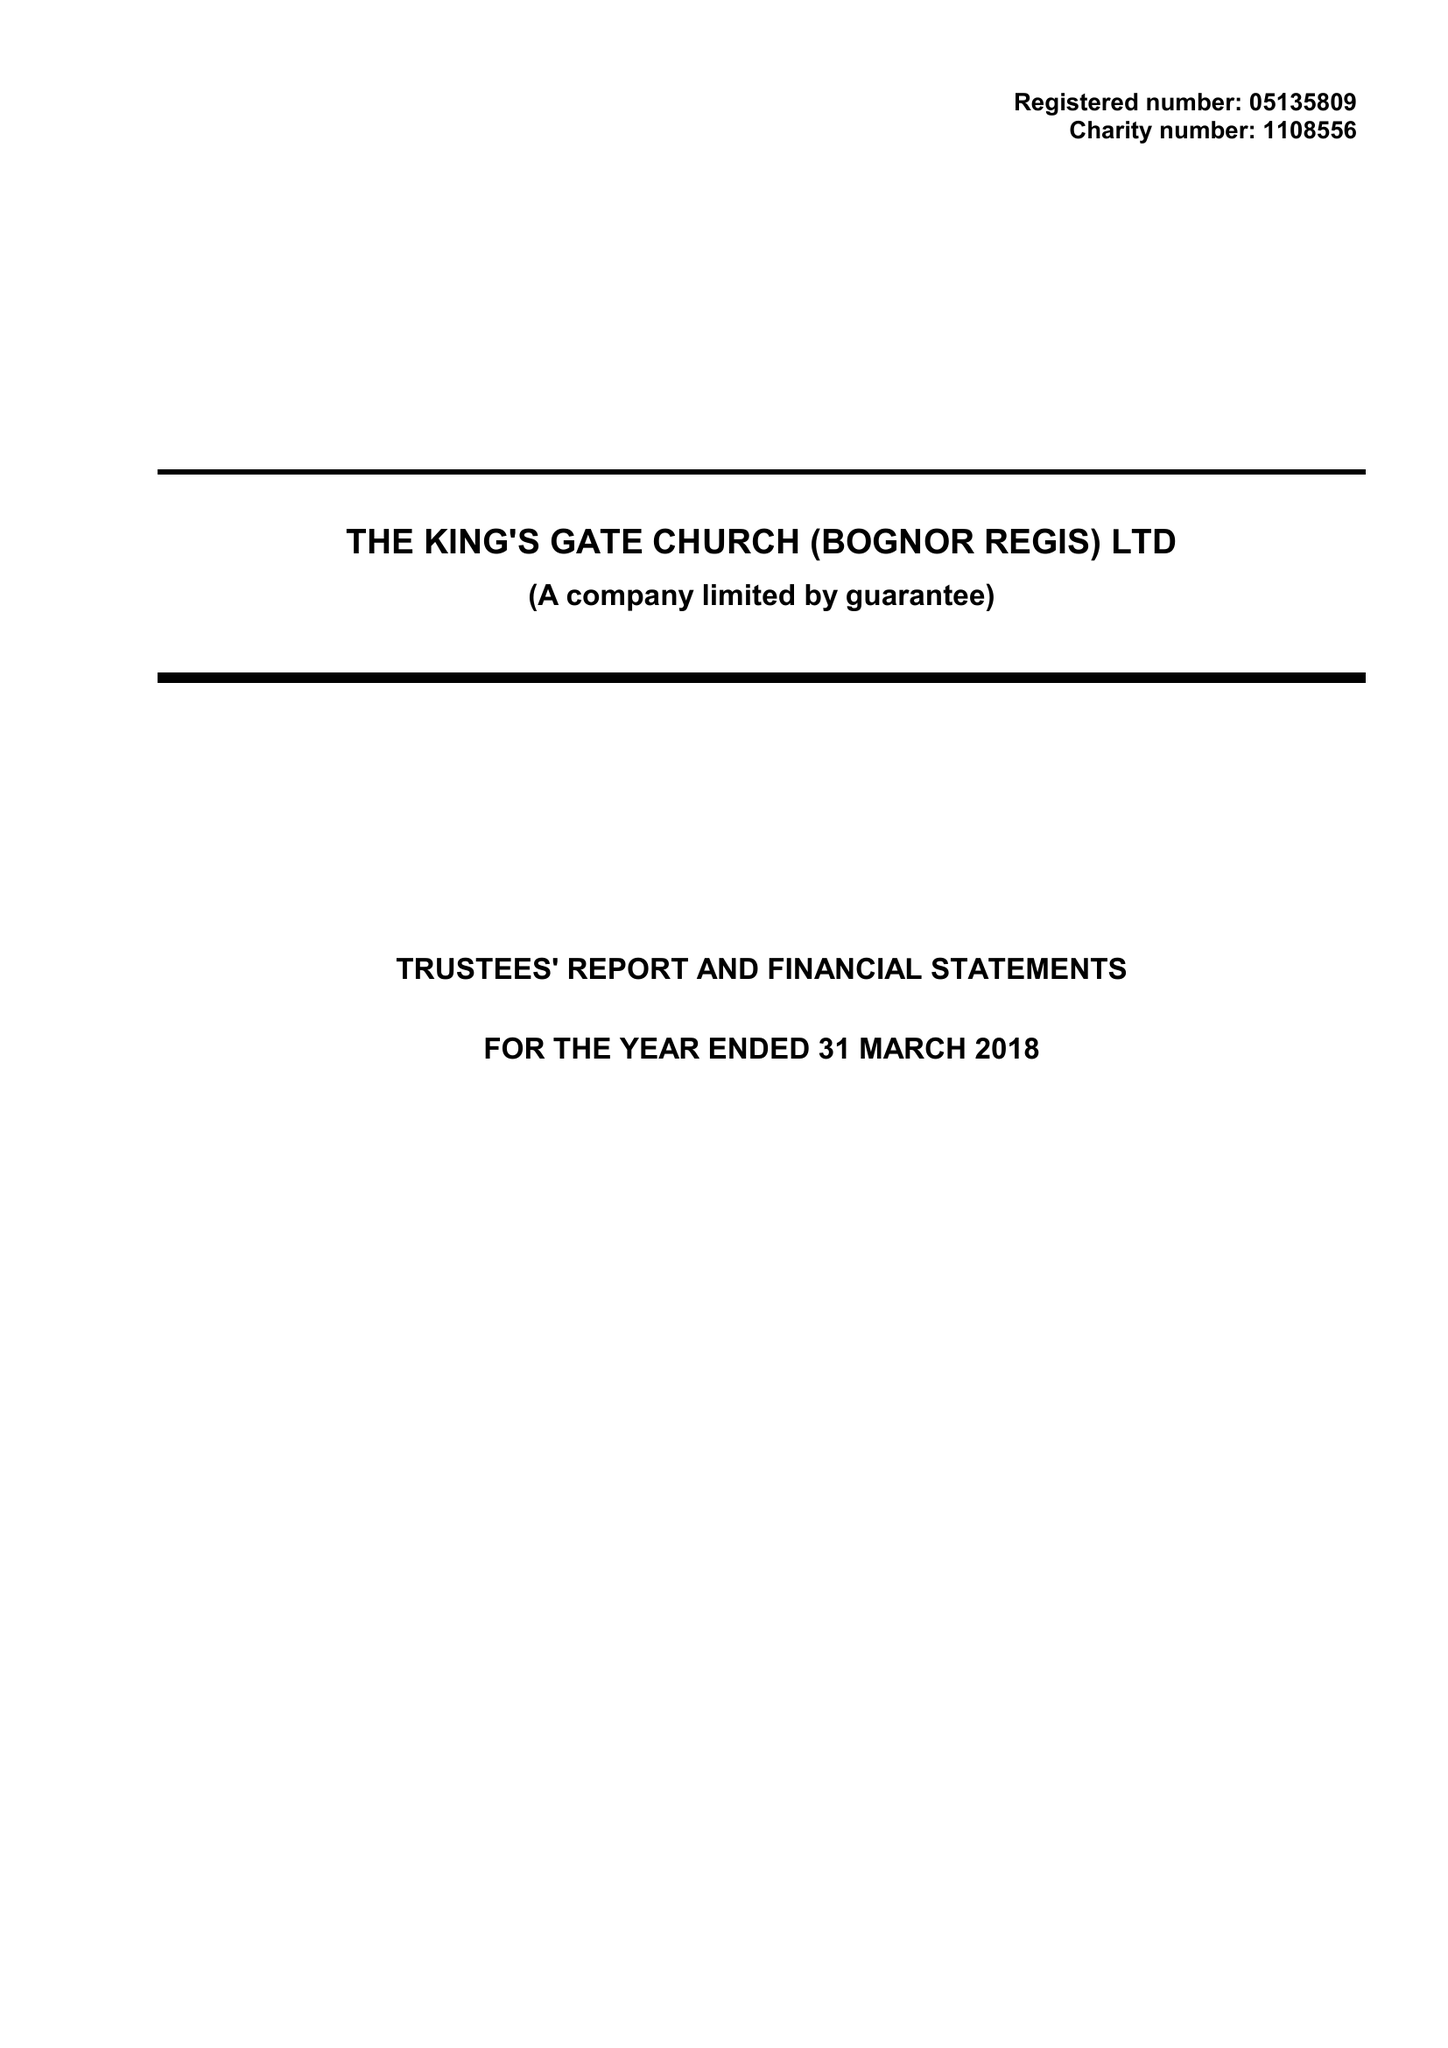What is the value for the charity_number?
Answer the question using a single word or phrase. 1108556 